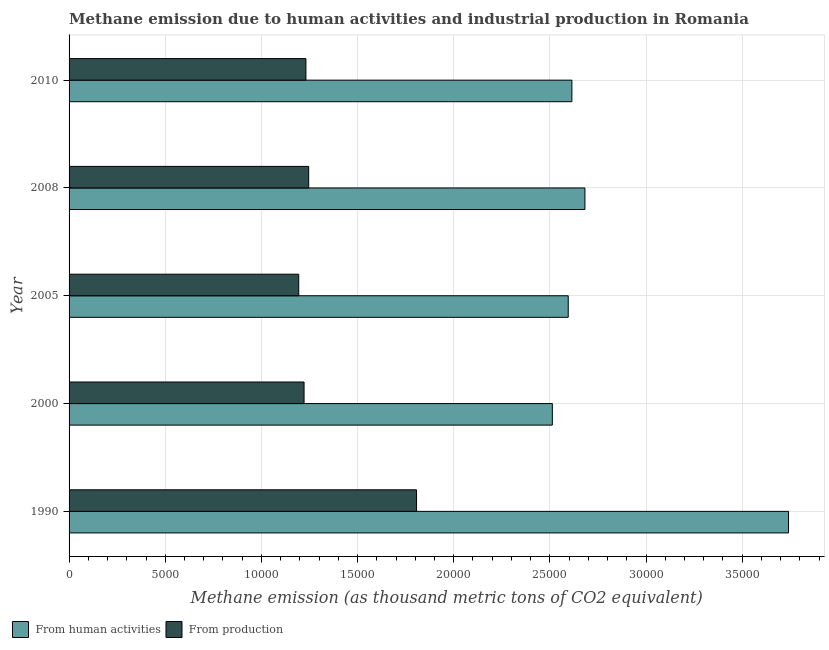How many groups of bars are there?
Your answer should be very brief. 5. How many bars are there on the 5th tick from the bottom?
Offer a terse response. 2. What is the label of the 1st group of bars from the top?
Your response must be concise. 2010. What is the amount of emissions generated from industries in 2000?
Provide a succinct answer. 1.22e+04. Across all years, what is the maximum amount of emissions generated from industries?
Provide a succinct answer. 1.81e+04. Across all years, what is the minimum amount of emissions generated from industries?
Make the answer very short. 1.19e+04. In which year was the amount of emissions generated from industries maximum?
Give a very brief answer. 1990. In which year was the amount of emissions generated from industries minimum?
Give a very brief answer. 2005. What is the total amount of emissions from human activities in the graph?
Provide a short and direct response. 1.41e+05. What is the difference between the amount of emissions generated from industries in 2000 and that in 2005?
Provide a short and direct response. 276.6. What is the difference between the amount of emissions generated from industries in 2008 and the amount of emissions from human activities in 1990?
Make the answer very short. -2.50e+04. What is the average amount of emissions generated from industries per year?
Your answer should be very brief. 1.34e+04. In the year 2008, what is the difference between the amount of emissions generated from industries and amount of emissions from human activities?
Your response must be concise. -1.44e+04. In how many years, is the amount of emissions from human activities greater than 6000 thousand metric tons?
Ensure brevity in your answer.  5. What is the ratio of the amount of emissions from human activities in 2005 to that in 2010?
Offer a terse response. 0.99. Is the difference between the amount of emissions from human activities in 1990 and 2008 greater than the difference between the amount of emissions generated from industries in 1990 and 2008?
Offer a very short reply. Yes. What is the difference between the highest and the second highest amount of emissions generated from industries?
Provide a short and direct response. 5609.2. What is the difference between the highest and the lowest amount of emissions from human activities?
Provide a succinct answer. 1.23e+04. Is the sum of the amount of emissions from human activities in 2000 and 2010 greater than the maximum amount of emissions generated from industries across all years?
Ensure brevity in your answer.  Yes. What does the 2nd bar from the top in 2010 represents?
Offer a very short reply. From human activities. What does the 1st bar from the bottom in 2005 represents?
Make the answer very short. From human activities. How many bars are there?
Provide a succinct answer. 10. What is the difference between two consecutive major ticks on the X-axis?
Your answer should be compact. 5000. Does the graph contain any zero values?
Keep it short and to the point. No. How are the legend labels stacked?
Provide a succinct answer. Horizontal. What is the title of the graph?
Your response must be concise. Methane emission due to human activities and industrial production in Romania. Does "Malaria" appear as one of the legend labels in the graph?
Ensure brevity in your answer.  No. What is the label or title of the X-axis?
Provide a succinct answer. Methane emission (as thousand metric tons of CO2 equivalent). What is the Methane emission (as thousand metric tons of CO2 equivalent) of From human activities in 1990?
Give a very brief answer. 3.74e+04. What is the Methane emission (as thousand metric tons of CO2 equivalent) in From production in 1990?
Provide a short and direct response. 1.81e+04. What is the Methane emission (as thousand metric tons of CO2 equivalent) in From human activities in 2000?
Keep it short and to the point. 2.51e+04. What is the Methane emission (as thousand metric tons of CO2 equivalent) in From production in 2000?
Offer a very short reply. 1.22e+04. What is the Methane emission (as thousand metric tons of CO2 equivalent) of From human activities in 2005?
Provide a short and direct response. 2.60e+04. What is the Methane emission (as thousand metric tons of CO2 equivalent) in From production in 2005?
Provide a succinct answer. 1.19e+04. What is the Methane emission (as thousand metric tons of CO2 equivalent) of From human activities in 2008?
Your answer should be compact. 2.68e+04. What is the Methane emission (as thousand metric tons of CO2 equivalent) in From production in 2008?
Offer a terse response. 1.25e+04. What is the Methane emission (as thousand metric tons of CO2 equivalent) of From human activities in 2010?
Your answer should be very brief. 2.61e+04. What is the Methane emission (as thousand metric tons of CO2 equivalent) of From production in 2010?
Your response must be concise. 1.23e+04. Across all years, what is the maximum Methane emission (as thousand metric tons of CO2 equivalent) of From human activities?
Your response must be concise. 3.74e+04. Across all years, what is the maximum Methane emission (as thousand metric tons of CO2 equivalent) in From production?
Keep it short and to the point. 1.81e+04. Across all years, what is the minimum Methane emission (as thousand metric tons of CO2 equivalent) of From human activities?
Provide a succinct answer. 2.51e+04. Across all years, what is the minimum Methane emission (as thousand metric tons of CO2 equivalent) in From production?
Provide a succinct answer. 1.19e+04. What is the total Methane emission (as thousand metric tons of CO2 equivalent) of From human activities in the graph?
Keep it short and to the point. 1.41e+05. What is the total Methane emission (as thousand metric tons of CO2 equivalent) in From production in the graph?
Ensure brevity in your answer.  6.70e+04. What is the difference between the Methane emission (as thousand metric tons of CO2 equivalent) in From human activities in 1990 and that in 2000?
Keep it short and to the point. 1.23e+04. What is the difference between the Methane emission (as thousand metric tons of CO2 equivalent) in From production in 1990 and that in 2000?
Provide a short and direct response. 5849.1. What is the difference between the Methane emission (as thousand metric tons of CO2 equivalent) in From human activities in 1990 and that in 2005?
Provide a short and direct response. 1.15e+04. What is the difference between the Methane emission (as thousand metric tons of CO2 equivalent) of From production in 1990 and that in 2005?
Make the answer very short. 6125.7. What is the difference between the Methane emission (as thousand metric tons of CO2 equivalent) in From human activities in 1990 and that in 2008?
Provide a succinct answer. 1.06e+04. What is the difference between the Methane emission (as thousand metric tons of CO2 equivalent) of From production in 1990 and that in 2008?
Your response must be concise. 5609.2. What is the difference between the Methane emission (as thousand metric tons of CO2 equivalent) in From human activities in 1990 and that in 2010?
Provide a succinct answer. 1.13e+04. What is the difference between the Methane emission (as thousand metric tons of CO2 equivalent) of From production in 1990 and that in 2010?
Make the answer very short. 5752.5. What is the difference between the Methane emission (as thousand metric tons of CO2 equivalent) in From human activities in 2000 and that in 2005?
Make the answer very short. -826. What is the difference between the Methane emission (as thousand metric tons of CO2 equivalent) of From production in 2000 and that in 2005?
Provide a short and direct response. 276.6. What is the difference between the Methane emission (as thousand metric tons of CO2 equivalent) in From human activities in 2000 and that in 2008?
Provide a succinct answer. -1694.4. What is the difference between the Methane emission (as thousand metric tons of CO2 equivalent) in From production in 2000 and that in 2008?
Keep it short and to the point. -239.9. What is the difference between the Methane emission (as thousand metric tons of CO2 equivalent) of From human activities in 2000 and that in 2010?
Provide a short and direct response. -1016.6. What is the difference between the Methane emission (as thousand metric tons of CO2 equivalent) in From production in 2000 and that in 2010?
Offer a very short reply. -96.6. What is the difference between the Methane emission (as thousand metric tons of CO2 equivalent) of From human activities in 2005 and that in 2008?
Your answer should be compact. -868.4. What is the difference between the Methane emission (as thousand metric tons of CO2 equivalent) of From production in 2005 and that in 2008?
Keep it short and to the point. -516.5. What is the difference between the Methane emission (as thousand metric tons of CO2 equivalent) in From human activities in 2005 and that in 2010?
Make the answer very short. -190.6. What is the difference between the Methane emission (as thousand metric tons of CO2 equivalent) of From production in 2005 and that in 2010?
Your answer should be compact. -373.2. What is the difference between the Methane emission (as thousand metric tons of CO2 equivalent) in From human activities in 2008 and that in 2010?
Give a very brief answer. 677.8. What is the difference between the Methane emission (as thousand metric tons of CO2 equivalent) of From production in 2008 and that in 2010?
Make the answer very short. 143.3. What is the difference between the Methane emission (as thousand metric tons of CO2 equivalent) in From human activities in 1990 and the Methane emission (as thousand metric tons of CO2 equivalent) in From production in 2000?
Your response must be concise. 2.52e+04. What is the difference between the Methane emission (as thousand metric tons of CO2 equivalent) in From human activities in 1990 and the Methane emission (as thousand metric tons of CO2 equivalent) in From production in 2005?
Offer a very short reply. 2.55e+04. What is the difference between the Methane emission (as thousand metric tons of CO2 equivalent) in From human activities in 1990 and the Methane emission (as thousand metric tons of CO2 equivalent) in From production in 2008?
Give a very brief answer. 2.50e+04. What is the difference between the Methane emission (as thousand metric tons of CO2 equivalent) of From human activities in 1990 and the Methane emission (as thousand metric tons of CO2 equivalent) of From production in 2010?
Ensure brevity in your answer.  2.51e+04. What is the difference between the Methane emission (as thousand metric tons of CO2 equivalent) of From human activities in 2000 and the Methane emission (as thousand metric tons of CO2 equivalent) of From production in 2005?
Offer a terse response. 1.32e+04. What is the difference between the Methane emission (as thousand metric tons of CO2 equivalent) in From human activities in 2000 and the Methane emission (as thousand metric tons of CO2 equivalent) in From production in 2008?
Make the answer very short. 1.27e+04. What is the difference between the Methane emission (as thousand metric tons of CO2 equivalent) in From human activities in 2000 and the Methane emission (as thousand metric tons of CO2 equivalent) in From production in 2010?
Make the answer very short. 1.28e+04. What is the difference between the Methane emission (as thousand metric tons of CO2 equivalent) of From human activities in 2005 and the Methane emission (as thousand metric tons of CO2 equivalent) of From production in 2008?
Keep it short and to the point. 1.35e+04. What is the difference between the Methane emission (as thousand metric tons of CO2 equivalent) of From human activities in 2005 and the Methane emission (as thousand metric tons of CO2 equivalent) of From production in 2010?
Give a very brief answer. 1.36e+04. What is the difference between the Methane emission (as thousand metric tons of CO2 equivalent) of From human activities in 2008 and the Methane emission (as thousand metric tons of CO2 equivalent) of From production in 2010?
Provide a short and direct response. 1.45e+04. What is the average Methane emission (as thousand metric tons of CO2 equivalent) in From human activities per year?
Your answer should be very brief. 2.83e+04. What is the average Methane emission (as thousand metric tons of CO2 equivalent) of From production per year?
Provide a succinct answer. 1.34e+04. In the year 1990, what is the difference between the Methane emission (as thousand metric tons of CO2 equivalent) in From human activities and Methane emission (as thousand metric tons of CO2 equivalent) in From production?
Make the answer very short. 1.93e+04. In the year 2000, what is the difference between the Methane emission (as thousand metric tons of CO2 equivalent) in From human activities and Methane emission (as thousand metric tons of CO2 equivalent) in From production?
Offer a very short reply. 1.29e+04. In the year 2005, what is the difference between the Methane emission (as thousand metric tons of CO2 equivalent) of From human activities and Methane emission (as thousand metric tons of CO2 equivalent) of From production?
Offer a terse response. 1.40e+04. In the year 2008, what is the difference between the Methane emission (as thousand metric tons of CO2 equivalent) of From human activities and Methane emission (as thousand metric tons of CO2 equivalent) of From production?
Your response must be concise. 1.44e+04. In the year 2010, what is the difference between the Methane emission (as thousand metric tons of CO2 equivalent) of From human activities and Methane emission (as thousand metric tons of CO2 equivalent) of From production?
Ensure brevity in your answer.  1.38e+04. What is the ratio of the Methane emission (as thousand metric tons of CO2 equivalent) of From human activities in 1990 to that in 2000?
Provide a succinct answer. 1.49. What is the ratio of the Methane emission (as thousand metric tons of CO2 equivalent) of From production in 1990 to that in 2000?
Offer a terse response. 1.48. What is the ratio of the Methane emission (as thousand metric tons of CO2 equivalent) in From human activities in 1990 to that in 2005?
Your answer should be very brief. 1.44. What is the ratio of the Methane emission (as thousand metric tons of CO2 equivalent) of From production in 1990 to that in 2005?
Keep it short and to the point. 1.51. What is the ratio of the Methane emission (as thousand metric tons of CO2 equivalent) in From human activities in 1990 to that in 2008?
Give a very brief answer. 1.39. What is the ratio of the Methane emission (as thousand metric tons of CO2 equivalent) of From production in 1990 to that in 2008?
Your response must be concise. 1.45. What is the ratio of the Methane emission (as thousand metric tons of CO2 equivalent) in From human activities in 1990 to that in 2010?
Offer a very short reply. 1.43. What is the ratio of the Methane emission (as thousand metric tons of CO2 equivalent) in From production in 1990 to that in 2010?
Make the answer very short. 1.47. What is the ratio of the Methane emission (as thousand metric tons of CO2 equivalent) of From human activities in 2000 to that in 2005?
Provide a succinct answer. 0.97. What is the ratio of the Methane emission (as thousand metric tons of CO2 equivalent) of From production in 2000 to that in 2005?
Keep it short and to the point. 1.02. What is the ratio of the Methane emission (as thousand metric tons of CO2 equivalent) in From human activities in 2000 to that in 2008?
Offer a very short reply. 0.94. What is the ratio of the Methane emission (as thousand metric tons of CO2 equivalent) of From production in 2000 to that in 2008?
Your answer should be very brief. 0.98. What is the ratio of the Methane emission (as thousand metric tons of CO2 equivalent) in From human activities in 2000 to that in 2010?
Your answer should be very brief. 0.96. What is the ratio of the Methane emission (as thousand metric tons of CO2 equivalent) in From human activities in 2005 to that in 2008?
Your response must be concise. 0.97. What is the ratio of the Methane emission (as thousand metric tons of CO2 equivalent) of From production in 2005 to that in 2008?
Your answer should be compact. 0.96. What is the ratio of the Methane emission (as thousand metric tons of CO2 equivalent) in From human activities in 2005 to that in 2010?
Keep it short and to the point. 0.99. What is the ratio of the Methane emission (as thousand metric tons of CO2 equivalent) in From production in 2005 to that in 2010?
Give a very brief answer. 0.97. What is the ratio of the Methane emission (as thousand metric tons of CO2 equivalent) of From human activities in 2008 to that in 2010?
Provide a short and direct response. 1.03. What is the ratio of the Methane emission (as thousand metric tons of CO2 equivalent) of From production in 2008 to that in 2010?
Your response must be concise. 1.01. What is the difference between the highest and the second highest Methane emission (as thousand metric tons of CO2 equivalent) of From human activities?
Offer a terse response. 1.06e+04. What is the difference between the highest and the second highest Methane emission (as thousand metric tons of CO2 equivalent) in From production?
Keep it short and to the point. 5609.2. What is the difference between the highest and the lowest Methane emission (as thousand metric tons of CO2 equivalent) of From human activities?
Keep it short and to the point. 1.23e+04. What is the difference between the highest and the lowest Methane emission (as thousand metric tons of CO2 equivalent) in From production?
Offer a terse response. 6125.7. 